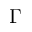<formula> <loc_0><loc_0><loc_500><loc_500>\Gamma</formula> 